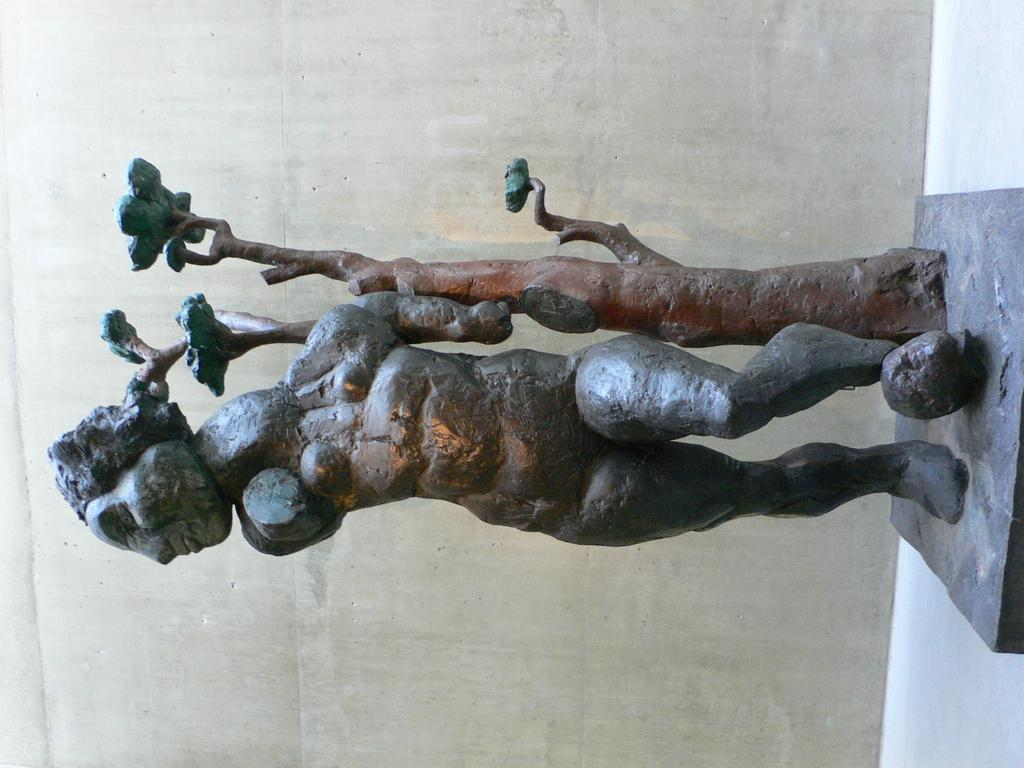What is the main subject of the image? The main subject of the image appears to be a sculpture. What does the sculpture depict? The sculpture depicts a person and a tree with leaves. What is the sculpture placed on? The sculpture is placed on a stone. How does the image look like? The image looks like a wall. How many cats are sleeping on the bed in the image? There are no cats or beds present in the image; it features a sculpture of a person and a tree on a stone. 